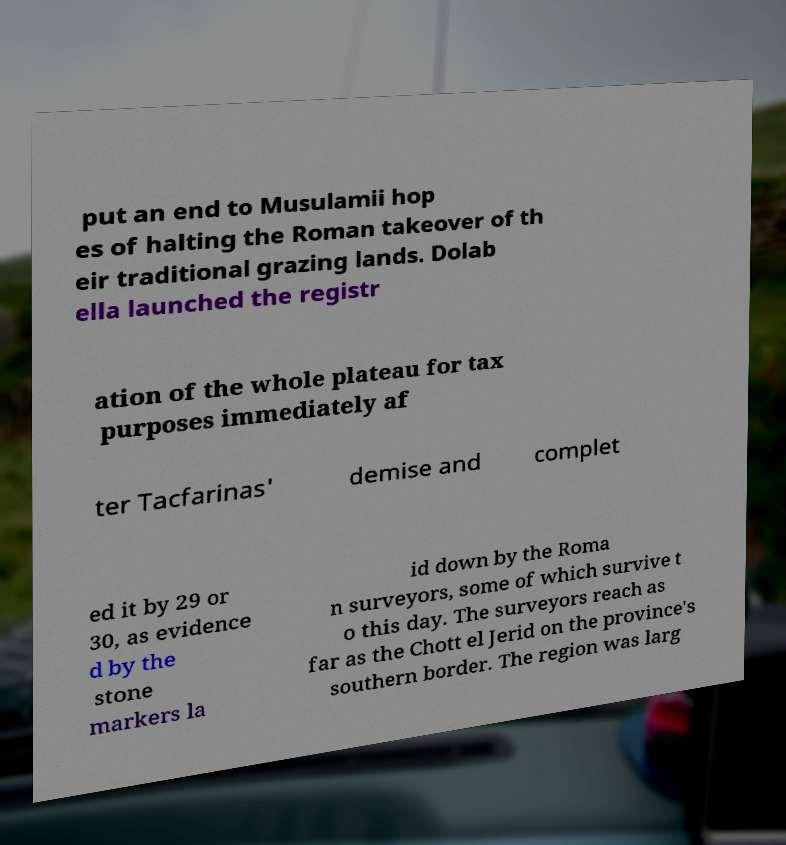What messages or text are displayed in this image? I need them in a readable, typed format. put an end to Musulamii hop es of halting the Roman takeover of th eir traditional grazing lands. Dolab ella launched the registr ation of the whole plateau for tax purposes immediately af ter Tacfarinas' demise and complet ed it by 29 or 30, as evidence d by the stone markers la id down by the Roma n surveyors, some of which survive t o this day. The surveyors reach as far as the Chott el Jerid on the province's southern border. The region was larg 